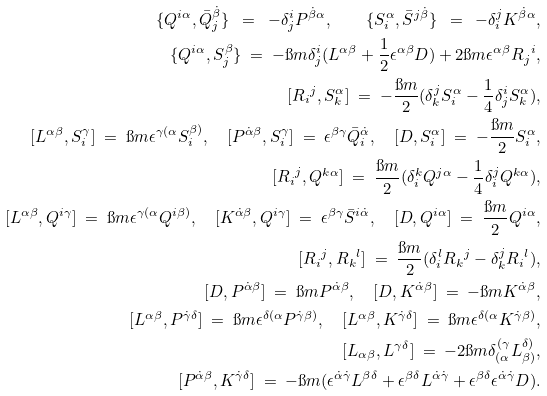<formula> <loc_0><loc_0><loc_500><loc_500>\{ Q ^ { i \alpha } , \bar { Q } ^ { \dot { \beta } } _ { j } \} \ = \ - \delta ^ { i } _ { j } P ^ { \dot { \beta } \alpha } , \quad \{ S ^ { \alpha } _ { i } , \bar { S } ^ { j \dot { \beta } } \} \ = \ - \delta _ { i } ^ { j } K ^ { \dot { \beta } \alpha } , \\ \{ Q ^ { i \alpha } , S ^ { \beta } _ { j } \} \ = \ - \i m \delta ^ { i } _ { j } ( L ^ { \alpha \beta } + \frac { 1 } { 2 } \epsilon ^ { \alpha \beta } D ) + 2 \i m \epsilon ^ { \alpha \beta } { R _ { j } } ^ { i } , \\ { [ { R _ { i } } ^ { j } , S ^ { \alpha } _ { k } ] } \ = \ - \frac { \i m } { 2 } ( \delta ^ { j } _ { k } S ^ { \alpha } _ { i } - \frac { 1 } { 4 } \delta ^ { i } _ { j } S ^ { \alpha } _ { k } ) , \\ { [ L ^ { \alpha \beta } , S ^ { \gamma } _ { i } ] } \ = \ \i m \epsilon ^ { \gamma ( \alpha } S ^ { \beta ) } _ { i } , \quad { [ P ^ { \dot { \alpha } \beta } , S ^ { \gamma } _ { i } ] } \ = \ \epsilon ^ { \beta \gamma } \bar { Q } ^ { \dot { \alpha } } _ { i } , \quad { [ D , S ^ { \alpha } _ { i } ] } \ = \ - \frac { \i m } { 2 } S ^ { \alpha } _ { i } , \\ { [ { R _ { i } } ^ { j } , Q ^ { k \alpha } ] } \ = \ \frac { \i m } { 2 } ( \delta ^ { k } _ { i } Q ^ { j \alpha } - \frac { 1 } { 4 } \delta ^ { j } _ { i } Q ^ { k \alpha } ) , \\ { [ L ^ { \alpha \beta } , Q ^ { i \gamma } ] } \ = \ \i m \epsilon ^ { \gamma ( \alpha } Q ^ { i \beta ) } , \quad { [ K ^ { \dot { \alpha } \beta } , Q ^ { i \gamma } ] } \ = \ \epsilon ^ { \beta \gamma } \bar { S } ^ { i \dot { \alpha } } , \quad { [ D , Q ^ { i \alpha } ] } \ = \ \frac { \i m } { 2 } Q ^ { i \alpha } , \\ { [ { R _ { i } } ^ { j } , { R _ { k } } ^ { l } ] } \ = \ \frac { \i m } { 2 } ( \delta ^ { l } _ { i } { R _ { k } } ^ { j } - \delta ^ { j } _ { k } { R _ { i } } ^ { l } ) , \\ { [ D , P ^ { \dot { \alpha } \beta } ] } \ = \ \i m P ^ { \dot { \alpha } \beta } , \quad { [ D , K ^ { \dot { \alpha } \beta } ] } \ = \ - \i m K ^ { \dot { \alpha } \beta } , \\ { [ L ^ { \alpha \beta } , P ^ { \dot { \gamma } \delta } ] } \ = \ \i m \epsilon ^ { \delta ( \alpha } P ^ { \dot { \gamma } \beta ) } , \quad { [ L ^ { \alpha \beta } , K ^ { \dot { \gamma } \delta } ] } \ = \ \i m \epsilon ^ { \delta ( \alpha } K ^ { \dot { \gamma } \beta ) } , \\ { [ L _ { \alpha \beta } , L ^ { \gamma \delta } ] } \ = \ - 2 \i m \delta _ { ( \alpha } ^ { ( \gamma } L _ { \beta ) } ^ { \delta ) } , \\ { [ P ^ { \dot { \alpha } \beta } , K ^ { \dot { \gamma } \delta } ] } \ = \ - \i m ( \epsilon ^ { \dot { \alpha } \dot { \gamma } } L ^ { \beta \delta } + \epsilon ^ { \beta \delta } L ^ { \dot { \alpha } \dot { \gamma } } + \epsilon ^ { \beta \delta } \epsilon ^ { \dot { \alpha } \dot { \gamma } } D ) .</formula> 